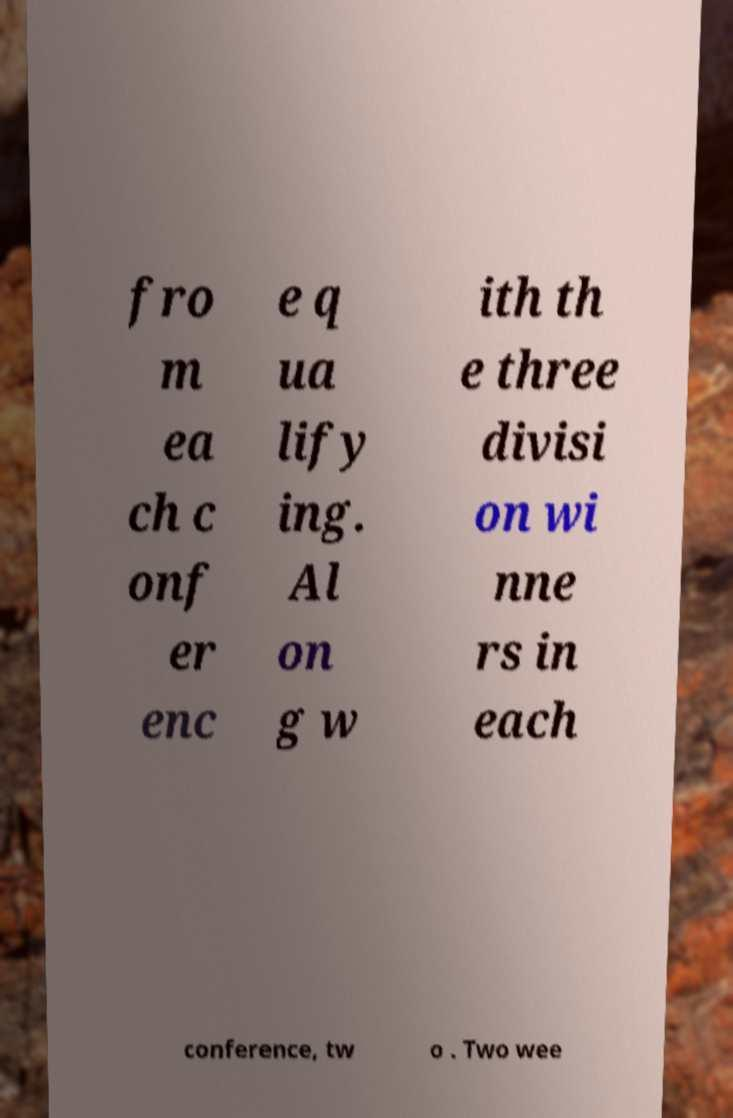Please read and relay the text visible in this image. What does it say? fro m ea ch c onf er enc e q ua lify ing. Al on g w ith th e three divisi on wi nne rs in each conference, tw o . Two wee 